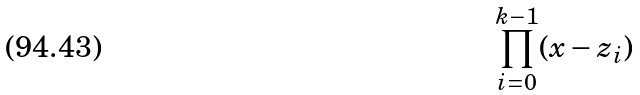<formula> <loc_0><loc_0><loc_500><loc_500>\prod _ { i = 0 } ^ { k - 1 } ( x - z _ { i } )</formula> 